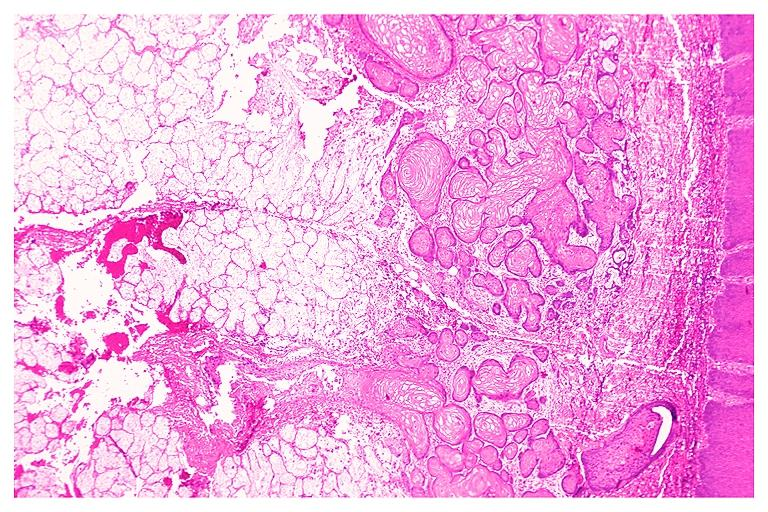what is present?
Answer the question using a single word or phrase. Oral 